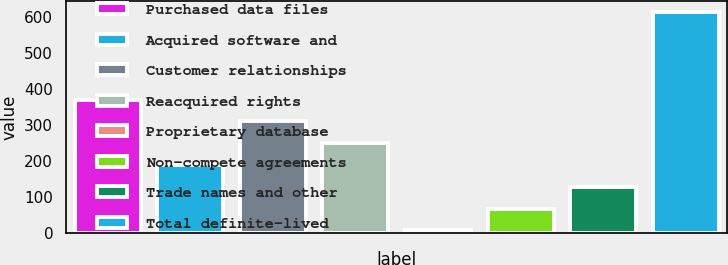Convert chart. <chart><loc_0><loc_0><loc_500><loc_500><bar_chart><fcel>Purchased data files<fcel>Acquired software and<fcel>Customer relationships<fcel>Reacquired rights<fcel>Proprietary database<fcel>Non-compete agreements<fcel>Trade names and other<fcel>Total definite-lived<nl><fcel>369.46<fcel>187.63<fcel>308.85<fcel>248.24<fcel>5.8<fcel>66.41<fcel>127.02<fcel>611.9<nl></chart> 